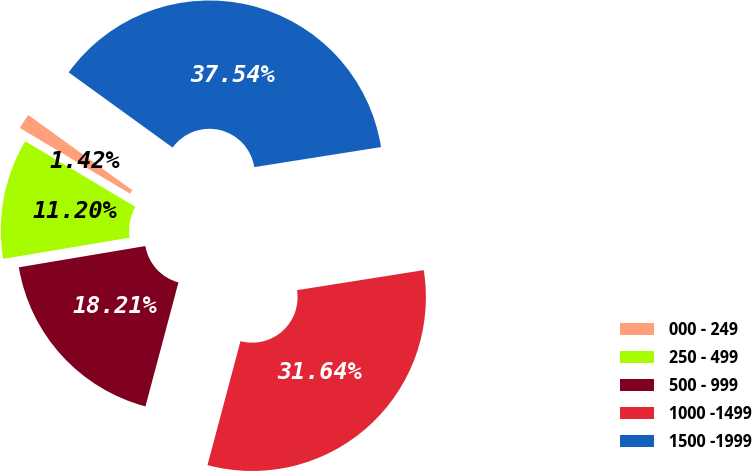Convert chart to OTSL. <chart><loc_0><loc_0><loc_500><loc_500><pie_chart><fcel>000 - 249<fcel>250 - 499<fcel>500 - 999<fcel>1000 -1499<fcel>1500 -1999<nl><fcel>1.42%<fcel>11.2%<fcel>18.21%<fcel>31.64%<fcel>37.54%<nl></chart> 